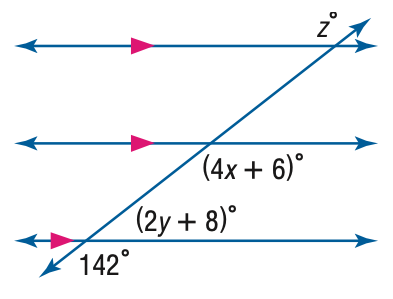Answer the mathemtical geometry problem and directly provide the correct option letter.
Question: Find z in the figure.
Choices: A: 132 B: 138 C: 142 D: 148 C 